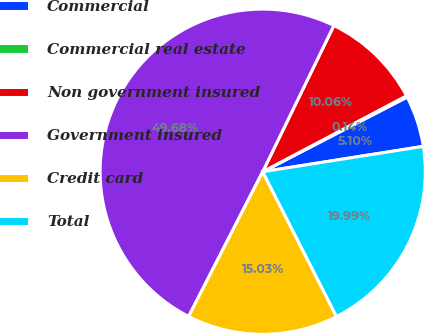Convert chart to OTSL. <chart><loc_0><loc_0><loc_500><loc_500><pie_chart><fcel>Commercial<fcel>Commercial real estate<fcel>Non government insured<fcel>Government insured<fcel>Credit card<fcel>Total<nl><fcel>5.1%<fcel>0.14%<fcel>10.06%<fcel>49.68%<fcel>15.03%<fcel>19.99%<nl></chart> 